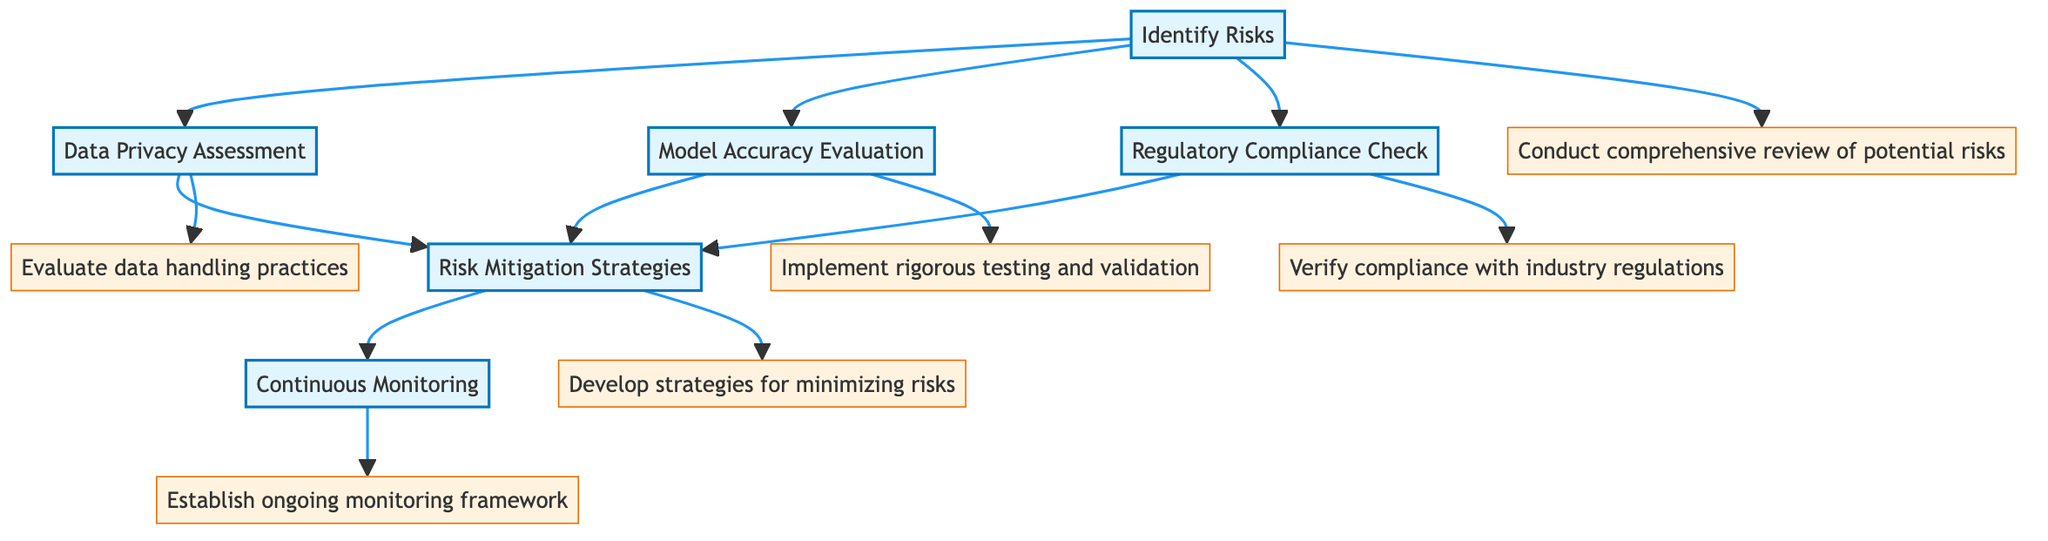What is the first step in the diagram? The first step in the flowchart is labeled "Identify Risks," which is the initial point in the process of risk management for algorithm implementation.
Answer: Identify Risks How many steps are represented in the diagram? There are six steps shown in the flowchart related to risk management strategies, each represented by a distinct node.
Answer: Six Which risk assessment step focuses on regulatory aspects? The step that addresses regulatory aspects is "Regulatory Compliance Check," ensuring the algorithm meets necessary legal requirements.
Answer: Regulatory Compliance Check What is the relationship between "Data Privacy Assessment" and "Risk Mitigation Strategies"? The "Data Privacy Assessment" directly leads to the "Risk Mitigation Strategies," meaning that completing an assessment informs the development of strategies to mitigate risks identified in that assessment.
Answer: Directly Leads To Which step follows "Model Accuracy Evaluation"? The step that follows "Model Accuracy Evaluation" is "Risk Mitigation Strategies," indicating that after evaluating the model's accuracy, strategies are developed to mitigate any identified issues.
Answer: Risk Mitigation Strategies How many descriptions are associated with the steps in the diagram? Each of the six steps includes a corresponding description, resulting in a total of six descriptions providing detailed information about the actions associated with each step.
Answer: Six What are the three main focus areas when identifying risks according to the diagram? The three focus areas for identifying risks are data sources, model outputs, and regulatory frameworks, as outlined in the "Identify Risks" step.
Answer: Data sources, model outputs, regulatory frameworks What does the "Continuous Monitoring" step involve? The "Continuous Monitoring" step involves establishing an ongoing framework to assess algorithm performance and compliance, which is critical for proactively identifying new risks.
Answer: Ongoing monitoring framework Which step is the last in the sequence of the flowchart? The last step in the flowchart is "Continuous Monitoring," indicating the final phase of the risk management strategy to ensure sustained oversight of risks associated with the algorithm.
Answer: Continuous Monitoring 